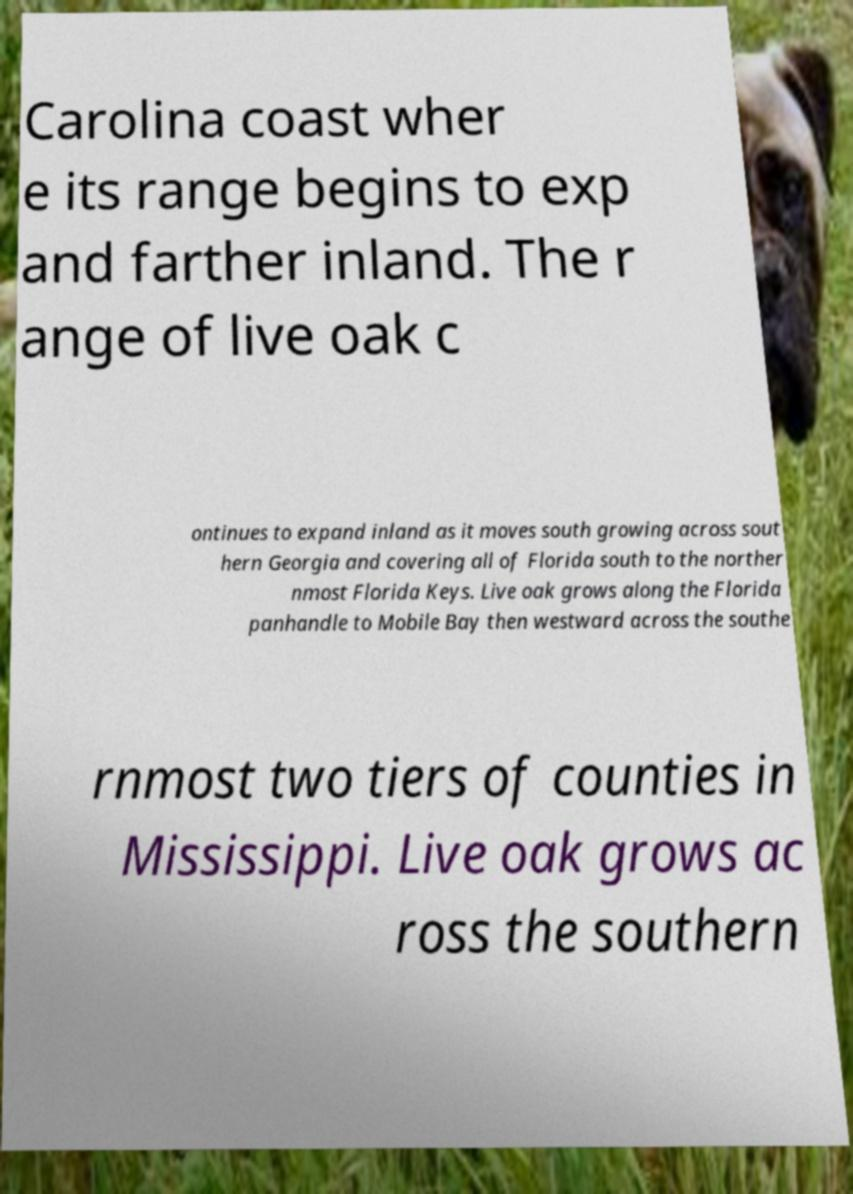What messages or text are displayed in this image? I need them in a readable, typed format. Carolina coast wher e its range begins to exp and farther inland. The r ange of live oak c ontinues to expand inland as it moves south growing across sout hern Georgia and covering all of Florida south to the norther nmost Florida Keys. Live oak grows along the Florida panhandle to Mobile Bay then westward across the southe rnmost two tiers of counties in Mississippi. Live oak grows ac ross the southern 